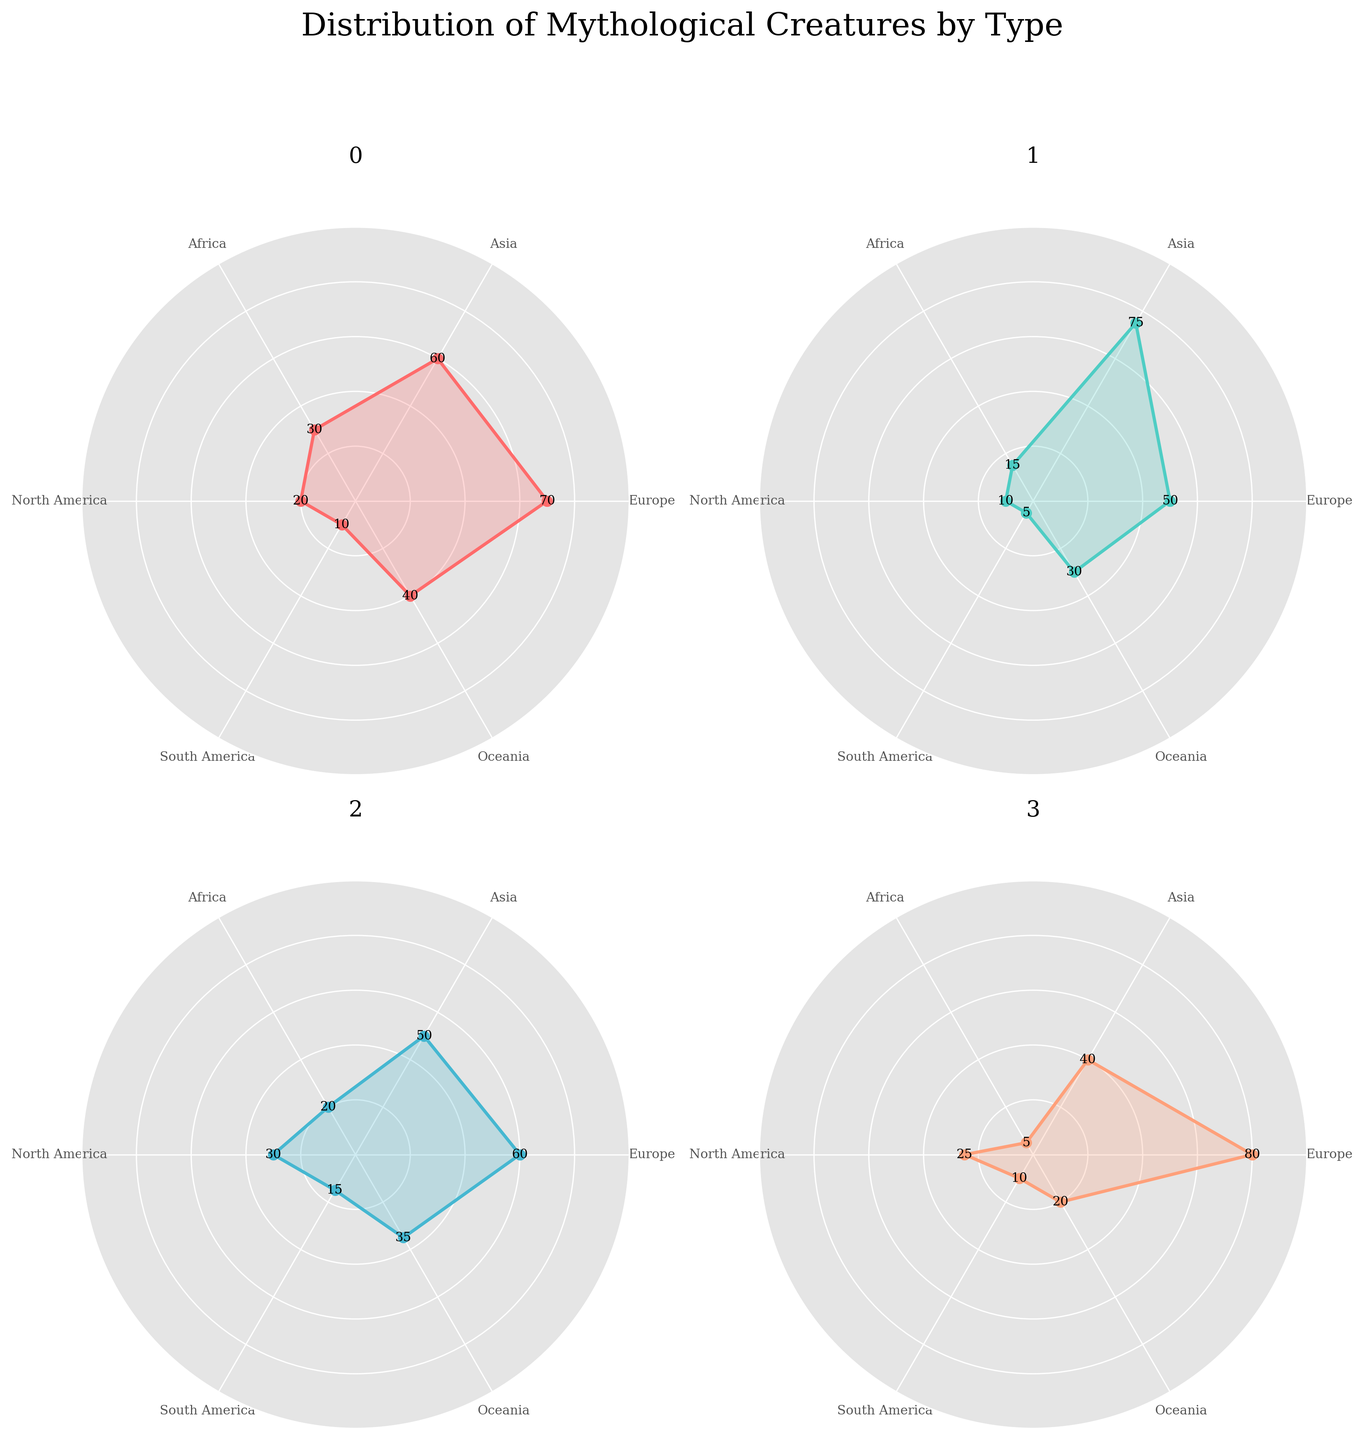Which type of mythological creature has the highest representation in Europe? By examining the subplot for each mythological creature, look for the highest data point in the Europe section. Dragons have a representation of 70, Phoenixes 50, Mermaids 60, and Unicorns 80. Unicorns have the highest representation in Europe.
Answer: Unicorns Which region has the lowest representation of mermaids? In the Mermaids subplot, compare the data points for each region. Europe: 60, Asia: 50, Africa: 20, North America: 30, South America: 15, Oceania: 35. South America has the lowest representation at 15.
Answer: South America In which region do dragons and unicorns have the same representation? Check the subplots for Dragons and Unicorns to find a region where the values match. Both in North America have 20.
Answer: North America Which mythological creature has the highest variance in representation across all regions? Calculate the variance for each creature by looking at the differences between their highest and lowest values. Dragons' values range from 10 to 70 (variance: 60), Phoenixes from 5 to 75 (variance: 70), Mermaids from 15 to 60 (variance: 45), and Unicorns from 5 to 80 (variance: 75). Unicorns have the highest variance.
Answer: Unicorns How many regions have more than 50% representation of dragons? In the Dragons subplot, check each region's value to see if it exceeds 50. Europe: 70, Asia: 60, Africa: 30, North America: 20, South America: 10, Oceania: 40. Only Europe and Asia have values greater than 50.
Answer: 2 regions Which mythological creature has the most balanced distribution across all regions? The most balanced distribution would have the smallest variance. Calculate the ranges again: Dragons (60), Phoenixes (70), Mermaids (45), Unicorns (75). Mermaids have the smallest variance (45), suggesting a more balanced distribution.
Answer: Mermaids What is the average representation of Phoenixes across all regions? To find the average, sum the values and divide by the number of regions: (50+75+15+10+5+30)/6 = 185/6 = 30.83.
Answer: 30.83 Compare the representation of Unicorns in Europe and Asia. Which region has more, and by how much? The Unicorn subplot shows Europe at 80 and Asia at 40. Europe has more, and the difference is 80-40 = 40.
Answer: Europe by 40 Which region has the most significant difference between the representation of Dragons and Phoenixes? Calculate the differences for each region: Europe (70-50=20), Asia (60-75=15), Africa (30-15=15), North America (20-10=10), South America (10-5=5), Oceania (40-30=10). Europe has the most significant difference (20).
Answer: Europe In which region are all four mythological creatures represented? Check each subplot to see if there's a value for each region. All regions except Africa have at least one creature represented with a value greater than 0. However, Africa misses Unicorns (value is 5, but Unicorns values start from 5 in this dataset). Therefore all creatures are represented.
Answer: All regions 